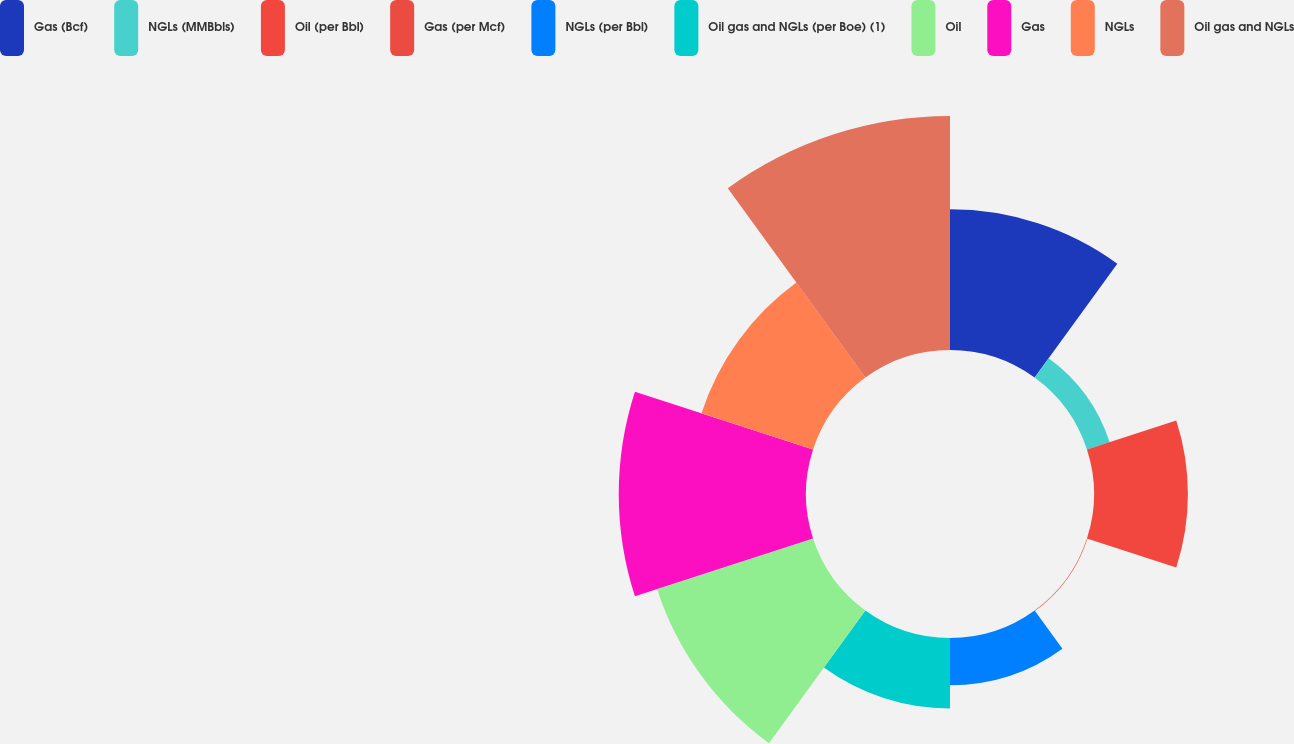Convert chart. <chart><loc_0><loc_0><loc_500><loc_500><pie_chart><fcel>Gas (Bcf)<fcel>NGLs (MMBbls)<fcel>Oil (per Bbl)<fcel>Gas (per Mcf)<fcel>NGLs (per Bbl)<fcel>Oil gas and NGLs (per Boe) (1)<fcel>Oil<fcel>Gas<fcel>NGLs<fcel>Oil gas and NGLs<nl><fcel>13.03%<fcel>2.21%<fcel>8.7%<fcel>0.05%<fcel>4.38%<fcel>6.54%<fcel>15.19%<fcel>17.35%<fcel>10.87%<fcel>21.68%<nl></chart> 